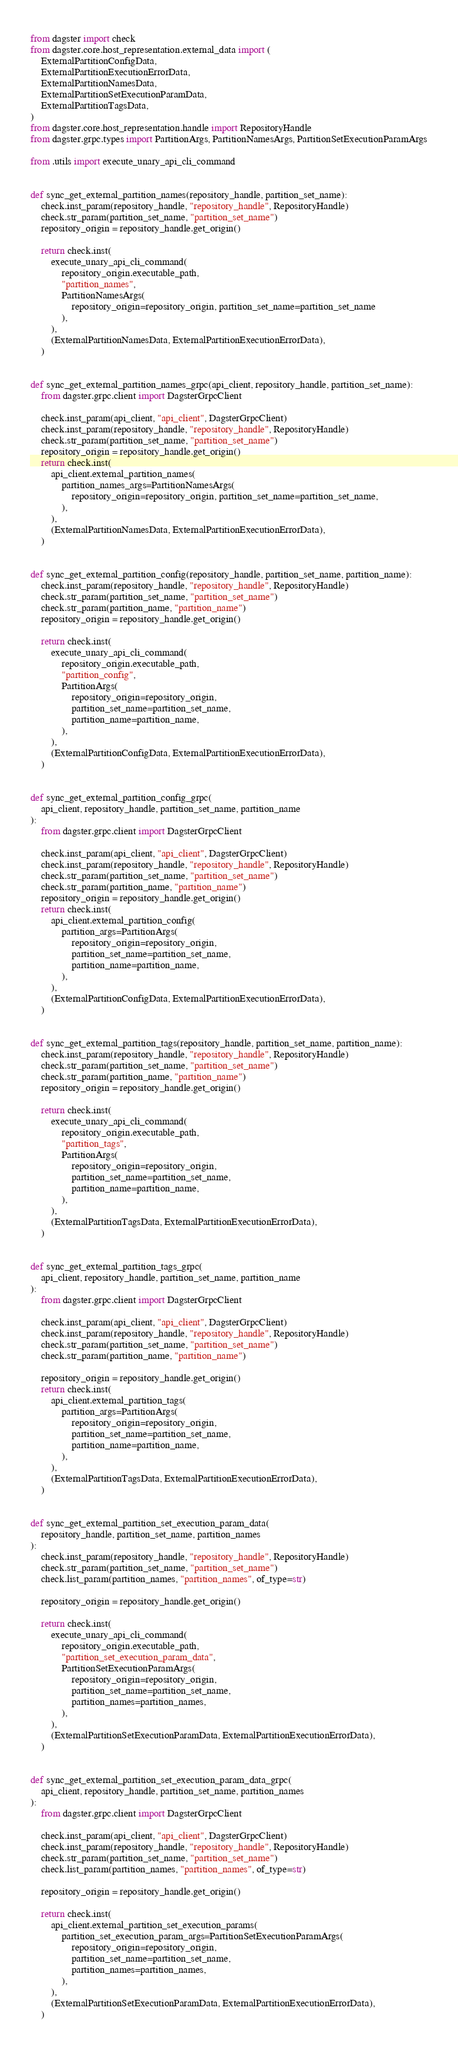<code> <loc_0><loc_0><loc_500><loc_500><_Python_>from dagster import check
from dagster.core.host_representation.external_data import (
    ExternalPartitionConfigData,
    ExternalPartitionExecutionErrorData,
    ExternalPartitionNamesData,
    ExternalPartitionSetExecutionParamData,
    ExternalPartitionTagsData,
)
from dagster.core.host_representation.handle import RepositoryHandle
from dagster.grpc.types import PartitionArgs, PartitionNamesArgs, PartitionSetExecutionParamArgs

from .utils import execute_unary_api_cli_command


def sync_get_external_partition_names(repository_handle, partition_set_name):
    check.inst_param(repository_handle, "repository_handle", RepositoryHandle)
    check.str_param(partition_set_name, "partition_set_name")
    repository_origin = repository_handle.get_origin()

    return check.inst(
        execute_unary_api_cli_command(
            repository_origin.executable_path,
            "partition_names",
            PartitionNamesArgs(
                repository_origin=repository_origin, partition_set_name=partition_set_name
            ),
        ),
        (ExternalPartitionNamesData, ExternalPartitionExecutionErrorData),
    )


def sync_get_external_partition_names_grpc(api_client, repository_handle, partition_set_name):
    from dagster.grpc.client import DagsterGrpcClient

    check.inst_param(api_client, "api_client", DagsterGrpcClient)
    check.inst_param(repository_handle, "repository_handle", RepositoryHandle)
    check.str_param(partition_set_name, "partition_set_name")
    repository_origin = repository_handle.get_origin()
    return check.inst(
        api_client.external_partition_names(
            partition_names_args=PartitionNamesArgs(
                repository_origin=repository_origin, partition_set_name=partition_set_name,
            ),
        ),
        (ExternalPartitionNamesData, ExternalPartitionExecutionErrorData),
    )


def sync_get_external_partition_config(repository_handle, partition_set_name, partition_name):
    check.inst_param(repository_handle, "repository_handle", RepositoryHandle)
    check.str_param(partition_set_name, "partition_set_name")
    check.str_param(partition_name, "partition_name")
    repository_origin = repository_handle.get_origin()

    return check.inst(
        execute_unary_api_cli_command(
            repository_origin.executable_path,
            "partition_config",
            PartitionArgs(
                repository_origin=repository_origin,
                partition_set_name=partition_set_name,
                partition_name=partition_name,
            ),
        ),
        (ExternalPartitionConfigData, ExternalPartitionExecutionErrorData),
    )


def sync_get_external_partition_config_grpc(
    api_client, repository_handle, partition_set_name, partition_name
):
    from dagster.grpc.client import DagsterGrpcClient

    check.inst_param(api_client, "api_client", DagsterGrpcClient)
    check.inst_param(repository_handle, "repository_handle", RepositoryHandle)
    check.str_param(partition_set_name, "partition_set_name")
    check.str_param(partition_name, "partition_name")
    repository_origin = repository_handle.get_origin()
    return check.inst(
        api_client.external_partition_config(
            partition_args=PartitionArgs(
                repository_origin=repository_origin,
                partition_set_name=partition_set_name,
                partition_name=partition_name,
            ),
        ),
        (ExternalPartitionConfigData, ExternalPartitionExecutionErrorData),
    )


def sync_get_external_partition_tags(repository_handle, partition_set_name, partition_name):
    check.inst_param(repository_handle, "repository_handle", RepositoryHandle)
    check.str_param(partition_set_name, "partition_set_name")
    check.str_param(partition_name, "partition_name")
    repository_origin = repository_handle.get_origin()

    return check.inst(
        execute_unary_api_cli_command(
            repository_origin.executable_path,
            "partition_tags",
            PartitionArgs(
                repository_origin=repository_origin,
                partition_set_name=partition_set_name,
                partition_name=partition_name,
            ),
        ),
        (ExternalPartitionTagsData, ExternalPartitionExecutionErrorData),
    )


def sync_get_external_partition_tags_grpc(
    api_client, repository_handle, partition_set_name, partition_name
):
    from dagster.grpc.client import DagsterGrpcClient

    check.inst_param(api_client, "api_client", DagsterGrpcClient)
    check.inst_param(repository_handle, "repository_handle", RepositoryHandle)
    check.str_param(partition_set_name, "partition_set_name")
    check.str_param(partition_name, "partition_name")

    repository_origin = repository_handle.get_origin()
    return check.inst(
        api_client.external_partition_tags(
            partition_args=PartitionArgs(
                repository_origin=repository_origin,
                partition_set_name=partition_set_name,
                partition_name=partition_name,
            ),
        ),
        (ExternalPartitionTagsData, ExternalPartitionExecutionErrorData),
    )


def sync_get_external_partition_set_execution_param_data(
    repository_handle, partition_set_name, partition_names
):
    check.inst_param(repository_handle, "repository_handle", RepositoryHandle)
    check.str_param(partition_set_name, "partition_set_name")
    check.list_param(partition_names, "partition_names", of_type=str)

    repository_origin = repository_handle.get_origin()

    return check.inst(
        execute_unary_api_cli_command(
            repository_origin.executable_path,
            "partition_set_execution_param_data",
            PartitionSetExecutionParamArgs(
                repository_origin=repository_origin,
                partition_set_name=partition_set_name,
                partition_names=partition_names,
            ),
        ),
        (ExternalPartitionSetExecutionParamData, ExternalPartitionExecutionErrorData),
    )


def sync_get_external_partition_set_execution_param_data_grpc(
    api_client, repository_handle, partition_set_name, partition_names
):
    from dagster.grpc.client import DagsterGrpcClient

    check.inst_param(api_client, "api_client", DagsterGrpcClient)
    check.inst_param(repository_handle, "repository_handle", RepositoryHandle)
    check.str_param(partition_set_name, "partition_set_name")
    check.list_param(partition_names, "partition_names", of_type=str)

    repository_origin = repository_handle.get_origin()

    return check.inst(
        api_client.external_partition_set_execution_params(
            partition_set_execution_param_args=PartitionSetExecutionParamArgs(
                repository_origin=repository_origin,
                partition_set_name=partition_set_name,
                partition_names=partition_names,
            ),
        ),
        (ExternalPartitionSetExecutionParamData, ExternalPartitionExecutionErrorData),
    )
</code> 